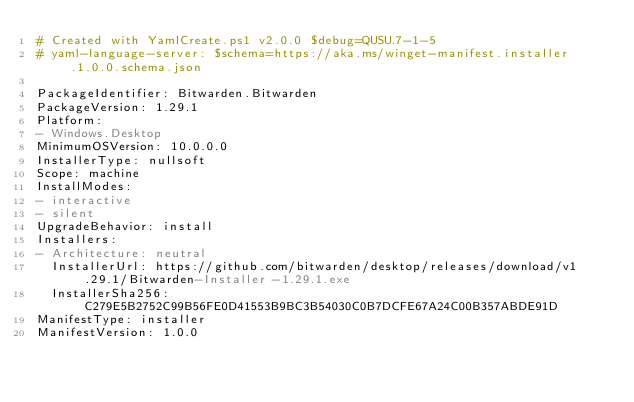Convert code to text. <code><loc_0><loc_0><loc_500><loc_500><_YAML_># Created with YamlCreate.ps1 v2.0.0 $debug=QUSU.7-1-5
# yaml-language-server: $schema=https://aka.ms/winget-manifest.installer.1.0.0.schema.json

PackageIdentifier: Bitwarden.Bitwarden
PackageVersion: 1.29.1
Platform:
- Windows.Desktop
MinimumOSVersion: 10.0.0.0
InstallerType: nullsoft
Scope: machine
InstallModes:
- interactive
- silent
UpgradeBehavior: install
Installers:
- Architecture: neutral
  InstallerUrl: https://github.com/bitwarden/desktop/releases/download/v1.29.1/Bitwarden-Installer-1.29.1.exe
  InstallerSha256: C279E5B2752C99B56FE0D41553B9BC3B54030C0B7DCFE67A24C00B357ABDE91D
ManifestType: installer
ManifestVersion: 1.0.0
</code> 